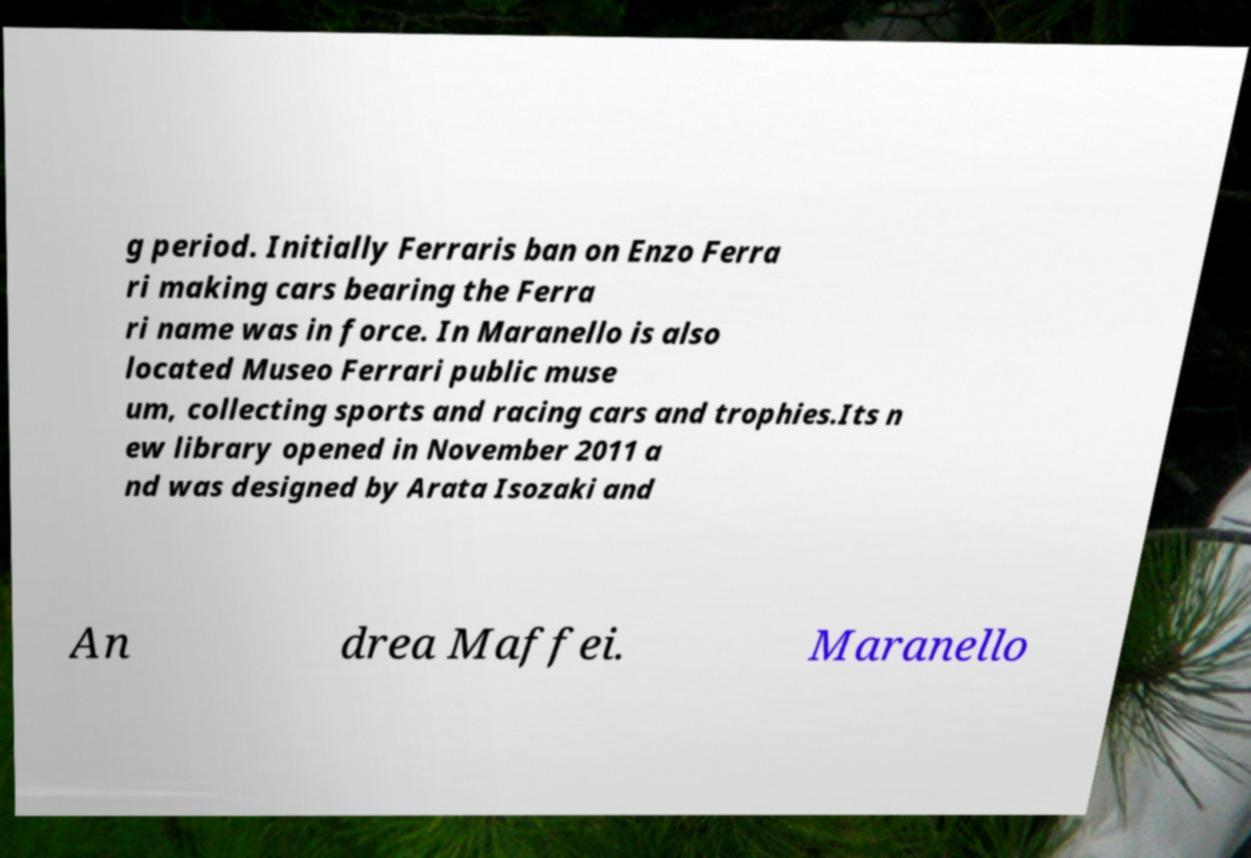Please read and relay the text visible in this image. What does it say? g period. Initially Ferraris ban on Enzo Ferra ri making cars bearing the Ferra ri name was in force. In Maranello is also located Museo Ferrari public muse um, collecting sports and racing cars and trophies.Its n ew library opened in November 2011 a nd was designed by Arata Isozaki and An drea Maffei. Maranello 